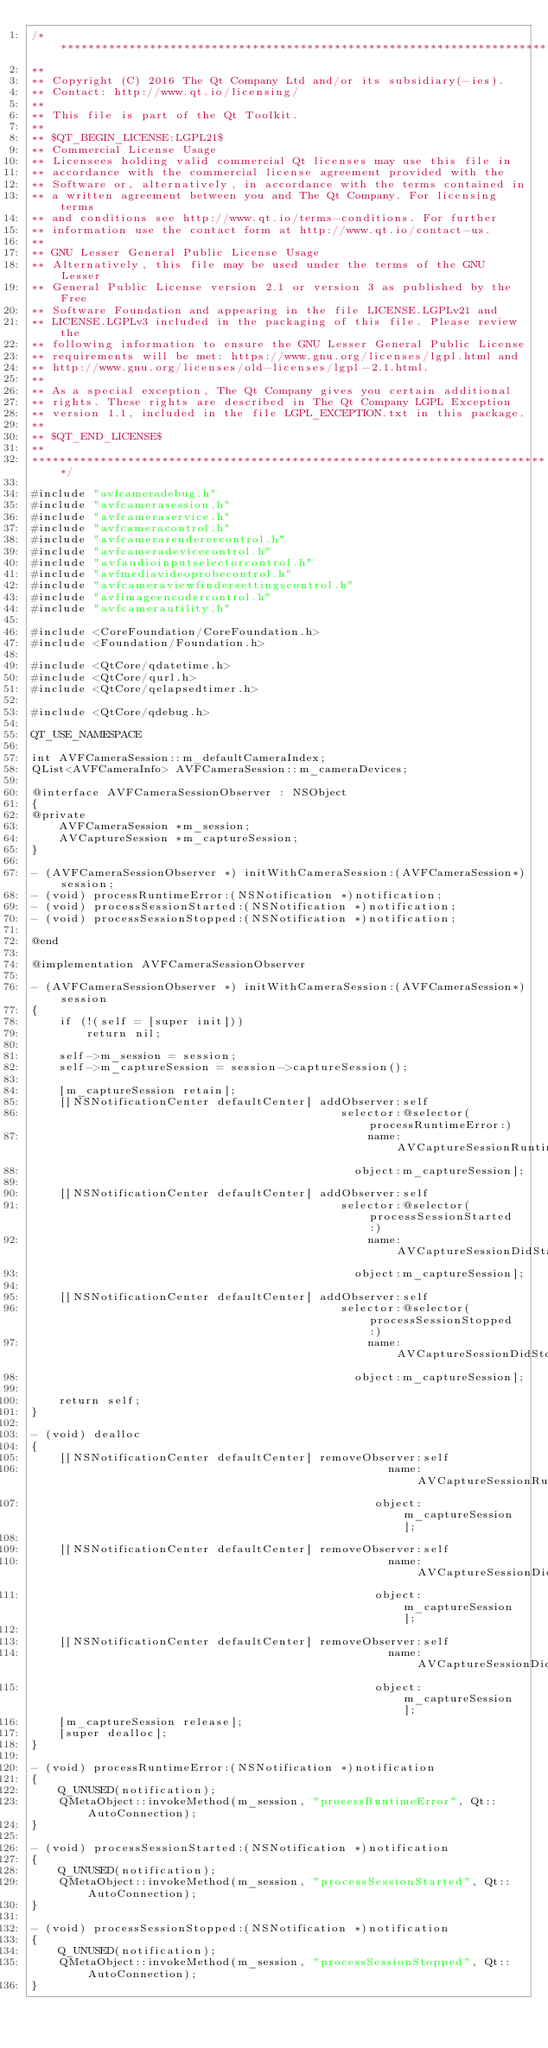Convert code to text. <code><loc_0><loc_0><loc_500><loc_500><_ObjectiveC_>/****************************************************************************
**
** Copyright (C) 2016 The Qt Company Ltd and/or its subsidiary(-ies).
** Contact: http://www.qt.io/licensing/
**
** This file is part of the Qt Toolkit.
**
** $QT_BEGIN_LICENSE:LGPL21$
** Commercial License Usage
** Licensees holding valid commercial Qt licenses may use this file in
** accordance with the commercial license agreement provided with the
** Software or, alternatively, in accordance with the terms contained in
** a written agreement between you and The Qt Company. For licensing terms
** and conditions see http://www.qt.io/terms-conditions. For further
** information use the contact form at http://www.qt.io/contact-us.
**
** GNU Lesser General Public License Usage
** Alternatively, this file may be used under the terms of the GNU Lesser
** General Public License version 2.1 or version 3 as published by the Free
** Software Foundation and appearing in the file LICENSE.LGPLv21 and
** LICENSE.LGPLv3 included in the packaging of this file. Please review the
** following information to ensure the GNU Lesser General Public License
** requirements will be met: https://www.gnu.org/licenses/lgpl.html and
** http://www.gnu.org/licenses/old-licenses/lgpl-2.1.html.
**
** As a special exception, The Qt Company gives you certain additional
** rights. These rights are described in The Qt Company LGPL Exception
** version 1.1, included in the file LGPL_EXCEPTION.txt in this package.
**
** $QT_END_LICENSE$
**
****************************************************************************/

#include "avfcameradebug.h"
#include "avfcamerasession.h"
#include "avfcameraservice.h"
#include "avfcameracontrol.h"
#include "avfcamerarenderercontrol.h"
#include "avfcameradevicecontrol.h"
#include "avfaudioinputselectorcontrol.h"
#include "avfmediavideoprobecontrol.h"
#include "avfcameraviewfindersettingscontrol.h"
#include "avfimageencodercontrol.h"
#include "avfcamerautility.h"

#include <CoreFoundation/CoreFoundation.h>
#include <Foundation/Foundation.h>

#include <QtCore/qdatetime.h>
#include <QtCore/qurl.h>
#include <QtCore/qelapsedtimer.h>

#include <QtCore/qdebug.h>

QT_USE_NAMESPACE

int AVFCameraSession::m_defaultCameraIndex;
QList<AVFCameraInfo> AVFCameraSession::m_cameraDevices;

@interface AVFCameraSessionObserver : NSObject
{
@private
    AVFCameraSession *m_session;
    AVCaptureSession *m_captureSession;
}

- (AVFCameraSessionObserver *) initWithCameraSession:(AVFCameraSession*)session;
- (void) processRuntimeError:(NSNotification *)notification;
- (void) processSessionStarted:(NSNotification *)notification;
- (void) processSessionStopped:(NSNotification *)notification;

@end

@implementation AVFCameraSessionObserver

- (AVFCameraSessionObserver *) initWithCameraSession:(AVFCameraSession*)session
{
    if (!(self = [super init]))
        return nil;

    self->m_session = session;
    self->m_captureSession = session->captureSession();

    [m_captureSession retain];
    [[NSNotificationCenter defaultCenter] addObserver:self
                                             selector:@selector(processRuntimeError:)
                                                 name:AVCaptureSessionRuntimeErrorNotification
                                               object:m_captureSession];

    [[NSNotificationCenter defaultCenter] addObserver:self
                                             selector:@selector(processSessionStarted:)
                                                 name:AVCaptureSessionDidStartRunningNotification
                                               object:m_captureSession];

    [[NSNotificationCenter defaultCenter] addObserver:self
                                             selector:@selector(processSessionStopped:)
                                                 name:AVCaptureSessionDidStopRunningNotification
                                               object:m_captureSession];

    return self;
}

- (void) dealloc
{
    [[NSNotificationCenter defaultCenter] removeObserver:self
                                                    name:AVCaptureSessionRuntimeErrorNotification
                                                  object:m_captureSession];

    [[NSNotificationCenter defaultCenter] removeObserver:self
                                                    name:AVCaptureSessionDidStartRunningNotification
                                                  object:m_captureSession];

    [[NSNotificationCenter defaultCenter] removeObserver:self
                                                    name:AVCaptureSessionDidStopRunningNotification
                                                  object:m_captureSession];
    [m_captureSession release];
    [super dealloc];
}

- (void) processRuntimeError:(NSNotification *)notification
{
    Q_UNUSED(notification);
    QMetaObject::invokeMethod(m_session, "processRuntimeError", Qt::AutoConnection);
}

- (void) processSessionStarted:(NSNotification *)notification
{
    Q_UNUSED(notification);
    QMetaObject::invokeMethod(m_session, "processSessionStarted", Qt::AutoConnection);
}

- (void) processSessionStopped:(NSNotification *)notification
{
    Q_UNUSED(notification);
    QMetaObject::invokeMethod(m_session, "processSessionStopped", Qt::AutoConnection);
}
</code> 